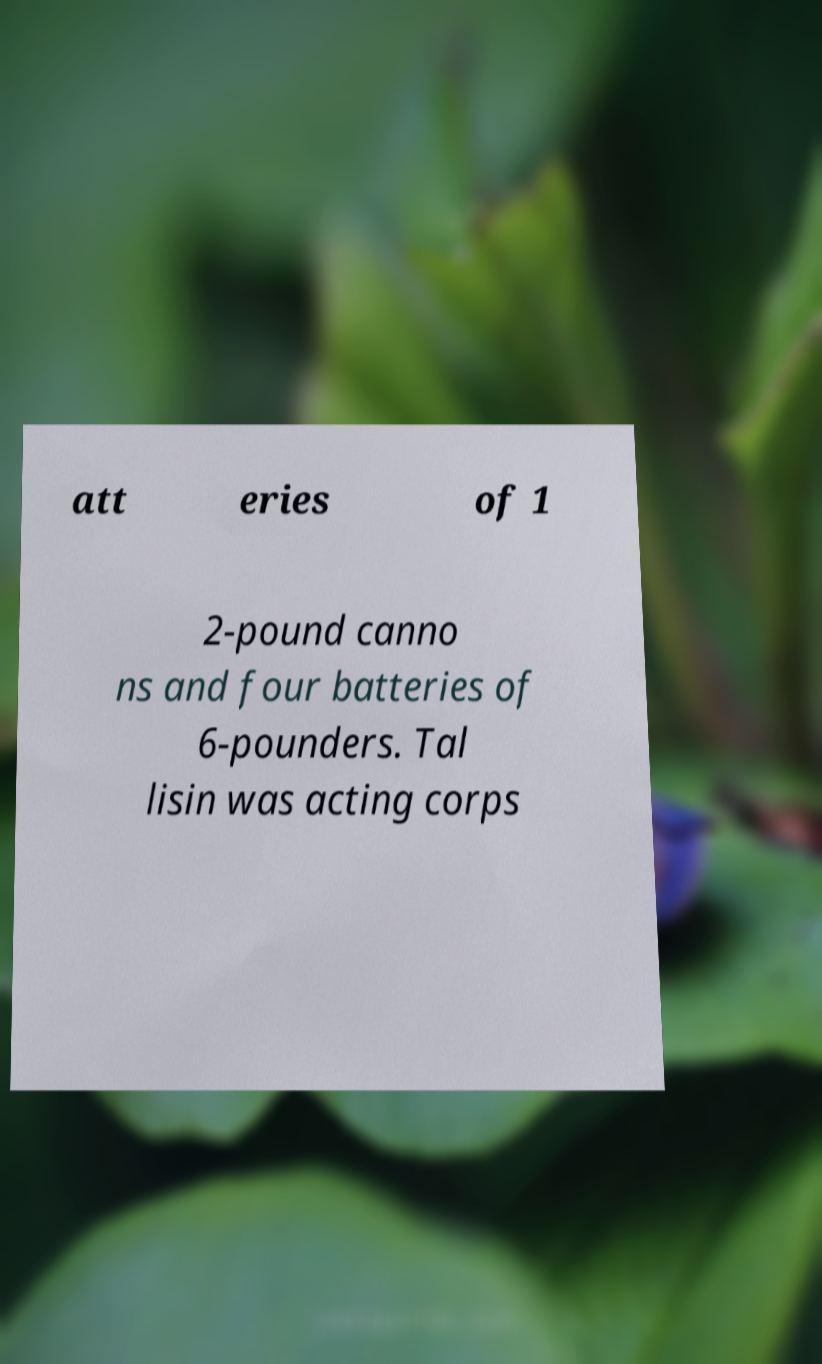For documentation purposes, I need the text within this image transcribed. Could you provide that? att eries of 1 2-pound canno ns and four batteries of 6-pounders. Tal lisin was acting corps 